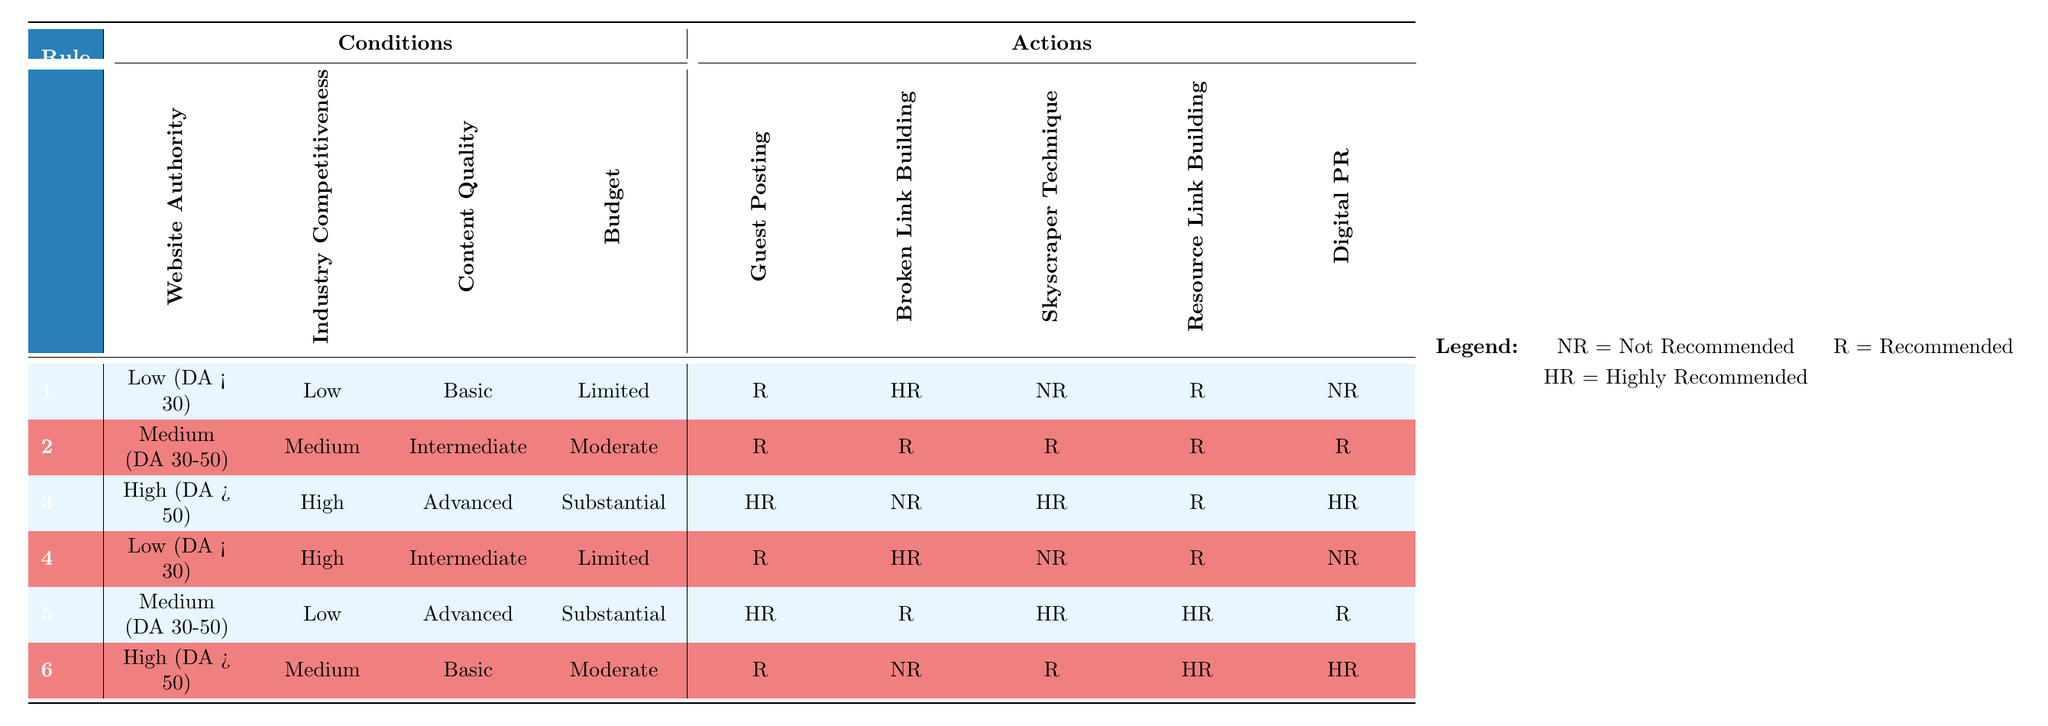What is the action recommended for High Authority, Low Competitiveness, Advanced Content, and Substantial Budget? In the table, I look for the row that corresponds to High Authority, Low Competitiveness, Advanced Content, and Substantial Budget. This combination matches rule 5, which indicates that the recommended action for that scenario is Highly Recommended for Guest Posting, Recommended for Broken Link Building, Highly Recommended for Skyscraper Technique, Highly Recommended for Resource Link Building, and Recommended for Digital PR.
Answer: Highly Recommended for Guest Posting, Recommended for Broken Link Building, Highly Recommended for Skyscraper Technique, Highly Recommended for Resource Link Building, Recommended for Digital PR Is Broken Link Building recommended for Medium Authority, Medium Competitiveness, Intermediate Content, and Moderate Budget? According to the table, I find the appropriate row for Medium Authority, Medium Competitiveness, Intermediate Content, and Moderate Budget, which is rule 2. Here, Broken Link Building is listed as Recommended.
Answer: Yes What is the action indicated for Low Authority, High Competitiveness, Intermediate Content, and Limited Budget? I look for the corresponding row in the table and identify that it fits the conditions described in rule 4. In that row, Broken Link Building is marked as Highly Recommended for this combination.
Answer: Highly Recommended What is the total number of recommended actions for High Authority, High Competitiveness, Advanced Content, and Substantial Budget? I locate rule 3 in the table that corresponds to High Authority, High Competitiveness, Advanced Content, and Substantial Budget. The actions indicated are Highly Recommended for Guest Posting, Not Recommended for Broken Link Building, Highly Recommended for Skyscraper Technique, Recommended for Resource Link Building, and Highly Recommended for Digital PR. The recommendations that are not marked as Not Recommended or for which the impact is highly praised can thus be added up as follows: 4 recommended actions.
Answer: 4 Are there any scenarios where Digital PR is Not Recommended? To answer this question, I scan the actions for each applicable row for any instance where Digital PR is marked as Not Recommended. This criterion is met in the row corresponding to Low Authority, Low Competitiveness, Basic Content, and Limited Budget (rule 1) and also by Low Authority, High Competitiveness, Intermediate Content, and Limited Budget (rule 4). Therefore, there are scenarios.
Answer: Yes What action is recommended for Medium Authority, Low Competitiveness, Basic Content, and Moderate Budget? I search through the table for the combination in question which corresponds to rule 6. For this row, the action is Library Science. Broken Link Building is listed as Not Recommended, while the other options are also evaluated. Conclusively, among options, is recommended.
Answer: Not Recommended 